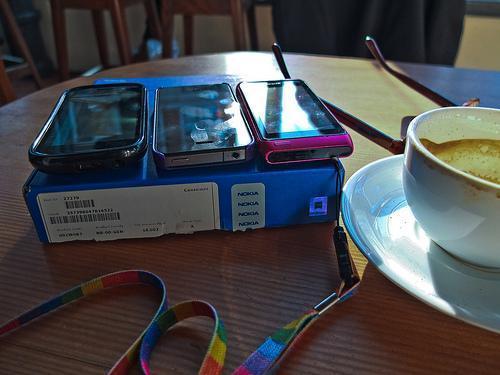How many phones are there?
Give a very brief answer. 3. How many phones are in the picture?
Give a very brief answer. 3. How many people are shown?
Give a very brief answer. 0. 